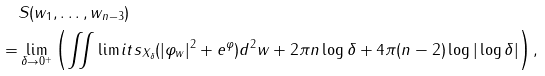<formula> <loc_0><loc_0><loc_500><loc_500>& S ( w _ { 1 } , \dots , w _ { n - 3 } ) \\ = & \lim _ { \delta \rightarrow 0 ^ { + } } \left ( \iint \lim i t s _ { X _ { \delta } } ( | \varphi _ { w } | ^ { 2 } + e ^ { \varphi } ) d ^ { 2 } w + 2 \pi n \log \delta + 4 \pi ( n - 2 ) \log | \log \delta | \right ) ,</formula> 